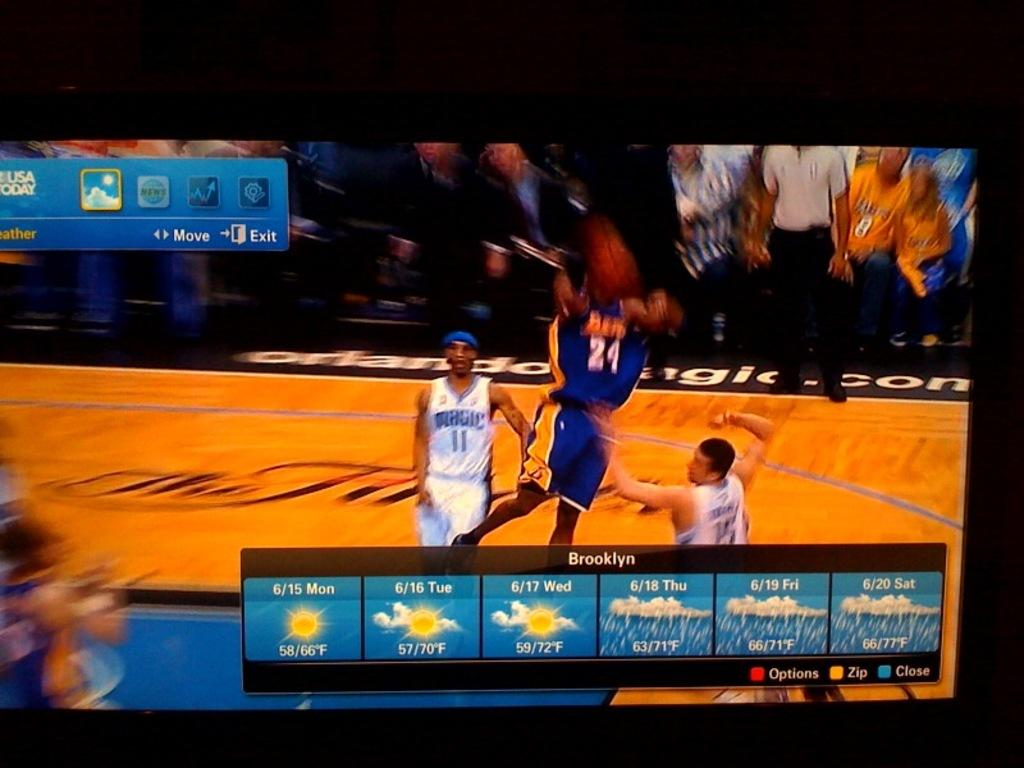<image>
Share a concise interpretation of the image provided. a basketball game on tv showing the weather for brooklyn 